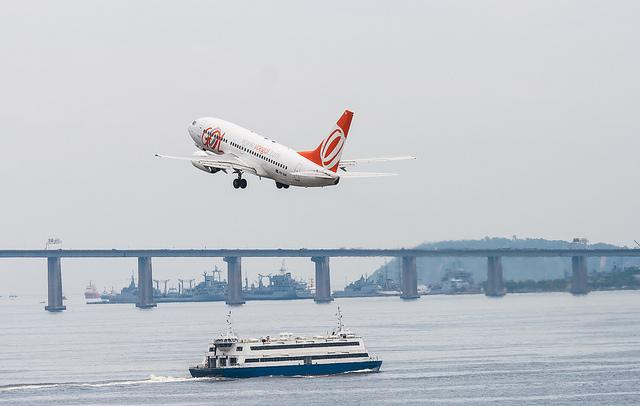What is the plane hovering over?

Choices:
A) ladder
B) cat
C) baby carriage
D) boat boat 